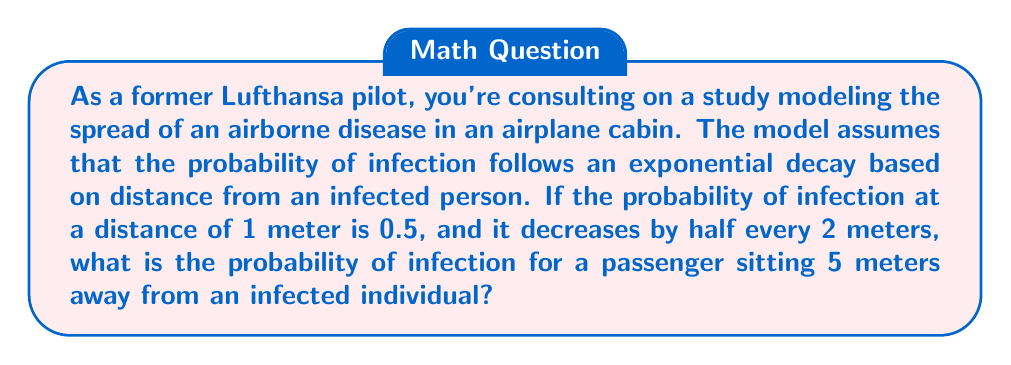Could you help me with this problem? Let's approach this step-by-step:

1) The model follows an exponential decay function. The general form of this function is:

   $$P(d) = P_0 \cdot e^{-\lambda d}$$

   Where:
   $P(d)$ is the probability at distance $d$
   $P_0$ is the initial probability (at $d=0$)
   $\lambda$ is the decay constant

2) We're given that at 1 meter, the probability is 0.5. Let's use this to find $P_0$:

   $$0.5 = P_0 \cdot e^{-\lambda}$$

3) We're also told that the probability halves every 2 meters. We can use this to find $\lambda$:

   $$\frac{1}{2} = e^{-2\lambda}$$

   Taking the natural log of both sides:

   $$\ln(\frac{1}{2}) = -2\lambda$$
   $$\lambda = \frac{\ln(2)}{2} \approx 0.3466$$

4) Now we can find $P_0$:

   $$0.5 = P_0 \cdot e^{-0.3466}$$
   $$P_0 = \frac{0.5}{e^{-0.3466}} \approx 0.7071$$

5) Our complete model is:

   $$P(d) = 0.7071 \cdot e^{-0.3466d}$$

6) To find the probability at 5 meters:

   $$P(5) = 0.7071 \cdot e^{-0.3466 \cdot 5} \approx 0.1250$$

Thus, the probability of infection at 5 meters is approximately 0.1250 or 12.50%.
Answer: The probability of infection for a passenger sitting 5 meters away from an infected individual is approximately 0.1250 or 12.50%. 